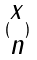<formula> <loc_0><loc_0><loc_500><loc_500>( \begin{matrix} x \\ n \end{matrix} )</formula> 